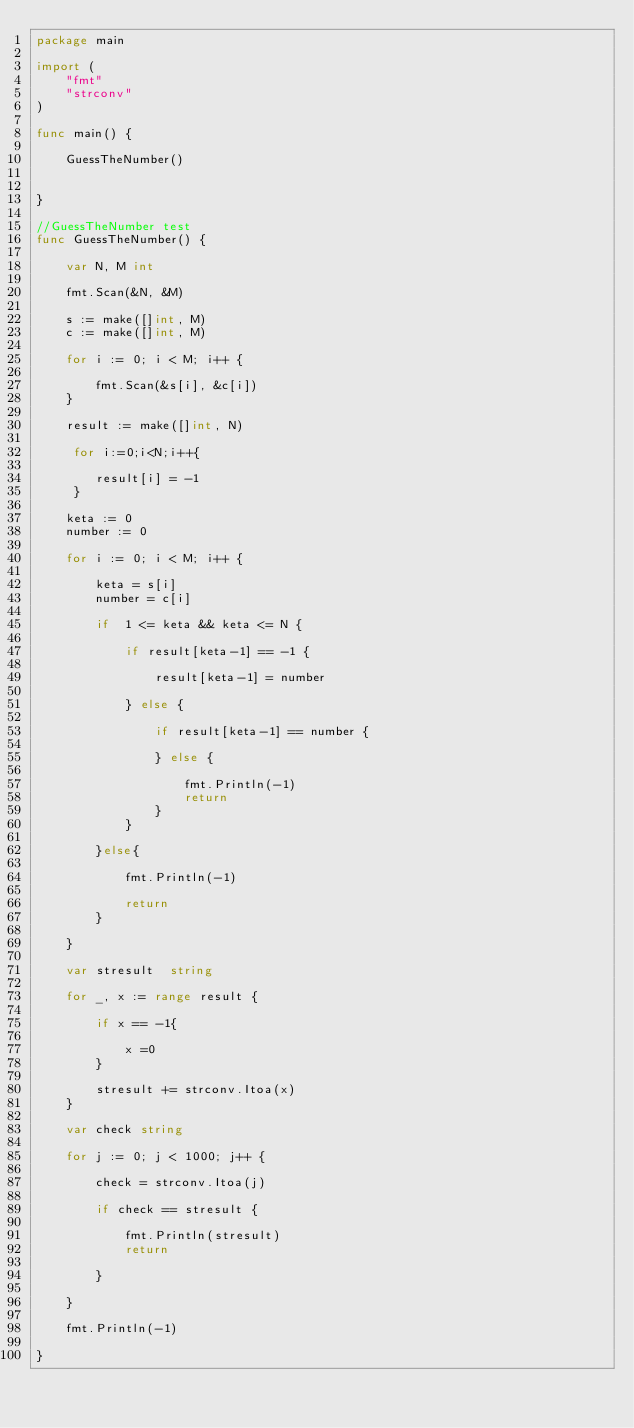Convert code to text. <code><loc_0><loc_0><loc_500><loc_500><_Go_>package main
 
import (
	"fmt"
	"strconv"
)

func main() {

	GuessTheNumber()


}

//GuessTheNumber test
func GuessTheNumber() {

	var N, M int

	fmt.Scan(&N, &M)

	s := make([]int, M)
	c := make([]int, M)

	for i := 0; i < M; i++ {

		fmt.Scan(&s[i], &c[i])
	}

	result := make([]int, N)

	 for i:=0;i<N;i++{

		result[i] = -1
	 }

	keta := 0
	number := 0

	for i := 0; i < M; i++ {

		keta = s[i]
		number = c[i]

		if  1 <= keta && keta <= N {

			if result[keta-1] == -1 {

				result[keta-1] = number

			} else {

				if result[keta-1] == number {

				} else {

					fmt.Println(-1)
					return
				}
			}

		}else{

			fmt.Println(-1)	
		
			return
		}

	}

	var stresult  string
	
	for _, x := range result {

		if x == -1{

			x =0
		}

		stresult += strconv.Itoa(x)
	}

	var check string

	for j := 0; j < 1000; j++ {

		check = strconv.Itoa(j)

		if check == stresult {

			fmt.Println(stresult)
			return

		}

	}

	fmt.Println(-1)

}</code> 